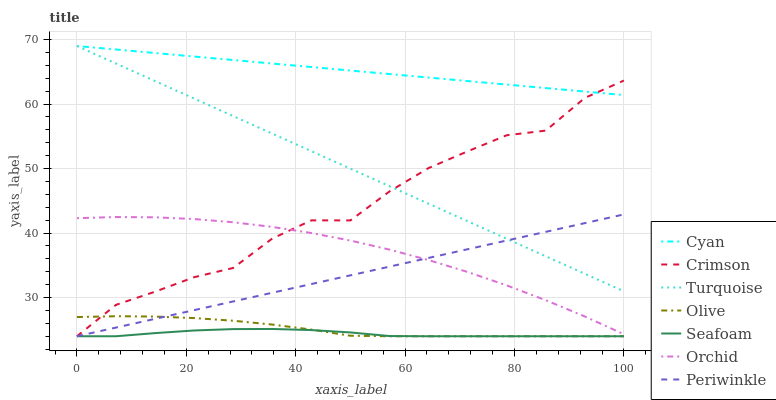Does Seafoam have the minimum area under the curve?
Answer yes or no. Yes. Does Cyan have the maximum area under the curve?
Answer yes or no. Yes. Does Olive have the minimum area under the curve?
Answer yes or no. No. Does Olive have the maximum area under the curve?
Answer yes or no. No. Is Periwinkle the smoothest?
Answer yes or no. Yes. Is Crimson the roughest?
Answer yes or no. Yes. Is Seafoam the smoothest?
Answer yes or no. No. Is Seafoam the roughest?
Answer yes or no. No. Does Seafoam have the lowest value?
Answer yes or no. Yes. Does Cyan have the lowest value?
Answer yes or no. No. Does Cyan have the highest value?
Answer yes or no. Yes. Does Olive have the highest value?
Answer yes or no. No. Is Olive less than Orchid?
Answer yes or no. Yes. Is Orchid greater than Seafoam?
Answer yes or no. Yes. Does Periwinkle intersect Seafoam?
Answer yes or no. Yes. Is Periwinkle less than Seafoam?
Answer yes or no. No. Is Periwinkle greater than Seafoam?
Answer yes or no. No. Does Olive intersect Orchid?
Answer yes or no. No. 